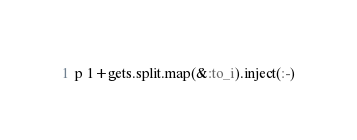<code> <loc_0><loc_0><loc_500><loc_500><_Ruby_>p 1+gets.split.map(&:to_i).inject(:-)</code> 